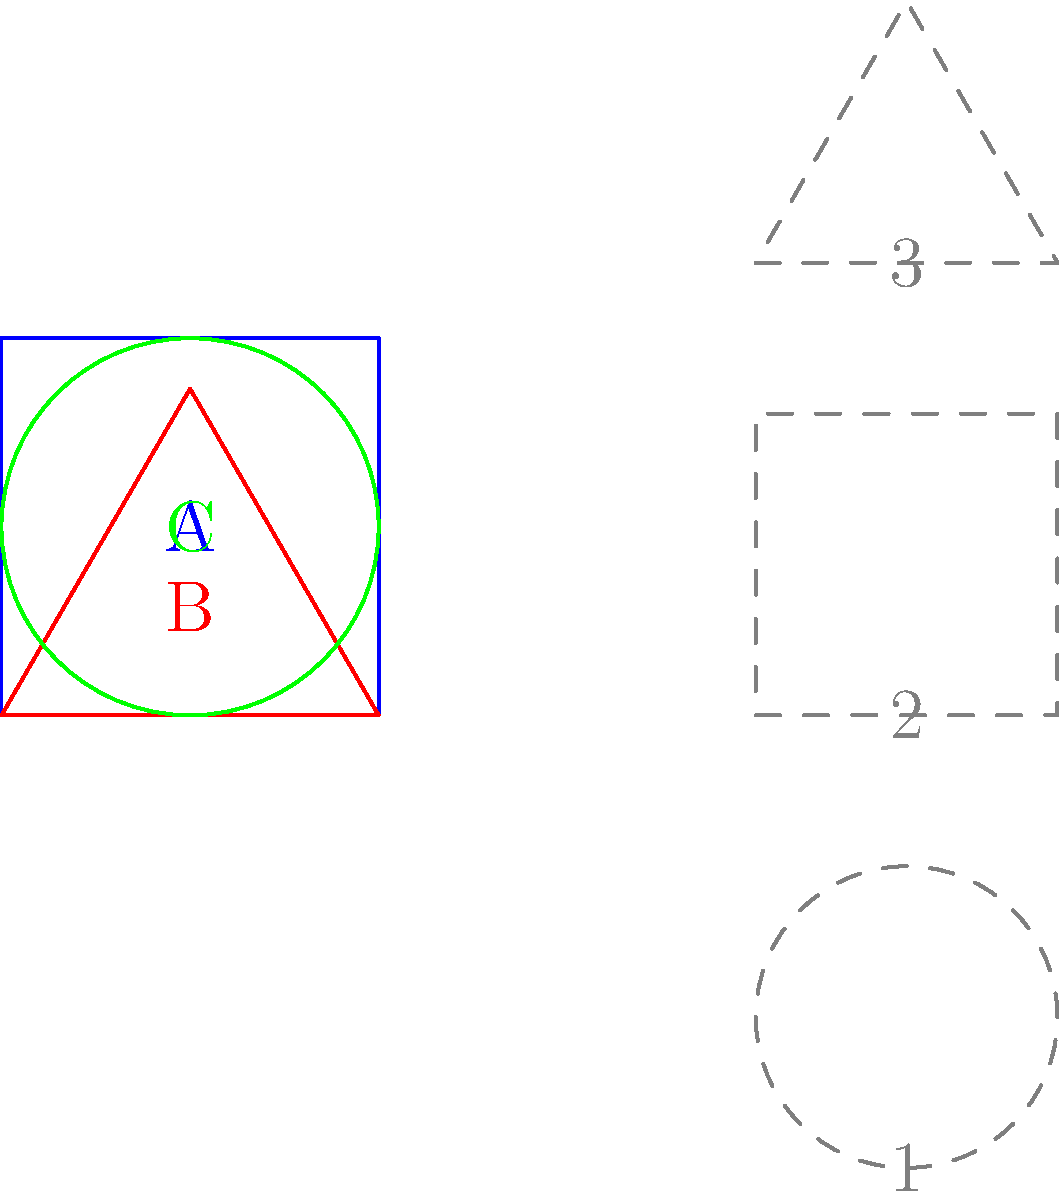Look at the colorful shapes on the left and the gray outlines on the right. Can you match each shape to its outline? Which number goes with each letter? Let's match each shape to its outline step by step:

1. Shape A (blue square):
   - Look for a square outline on the right.
   - The square outline is in the middle, labeled as 2.

2. Shape B (red triangle):
   - Find a triangle outline on the right.
   - The triangle outline is at the top, labeled as 3.

3. Shape C (green circle):
   - Search for a circle outline on the right.
   - The circle outline is at the bottom, labeled as 1.

So, we can match:
A (square) to 2
B (triangle) to 3
C (circle) to 1
Answer: A-2, B-3, C-1 